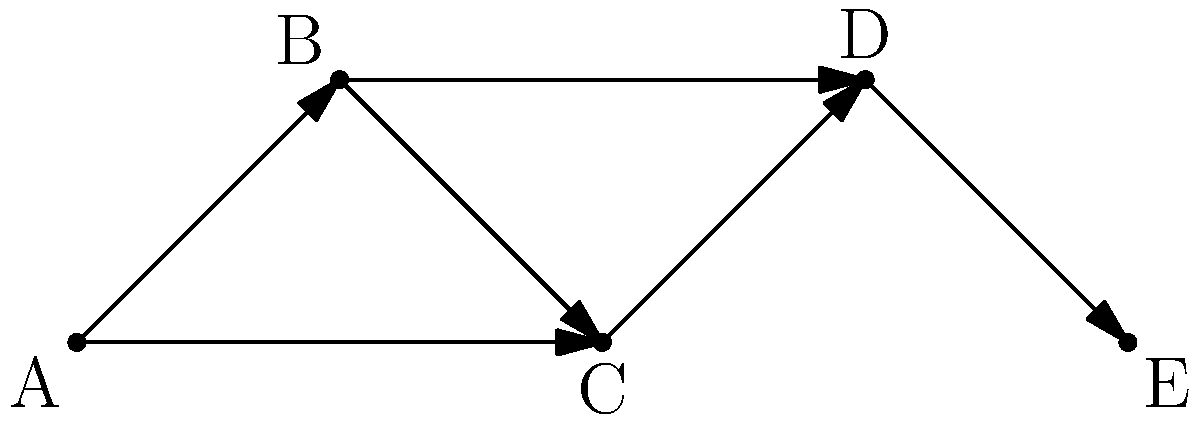In a trend network graph representing different clothing styles, each node represents a style, and directed edges indicate influence between styles. Given the graph above, where A represents "Streetwear," B represents "Minimalist," C represents "Bohemian," D represents "Elegant," and E represents "Vintage," what is the minimum number of edges that need to be removed to disconnect style A from style E? To solve this problem, we need to find the minimum cut between nodes A and E. Let's follow these steps:

1. Identify all possible paths from A to E:
   Path 1: A → B → D → E
   Path 2: A → C → D → E
   Path 3: A → B → C → D → E

2. Observe that all paths must go through node D to reach E. This means that removing the edge D → E would disconnect A from E.

3. Check if there's a solution with fewer edge removals:
   - Removing A → B and A → C would disconnect A from the rest of the graph, but this requires removing 2 edges.
   - Removing B → D and C → D would also disconnect A from E, but this also requires removing 2 edges.

4. Therefore, removing the single edge D → E is the minimum cut that disconnects A from E.

The minimum number of edges that need to be removed is 1, which is the edge connecting D to E.
Answer: 1 